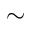<formula> <loc_0><loc_0><loc_500><loc_500>\sim</formula> 